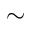<formula> <loc_0><loc_0><loc_500><loc_500>\sim</formula> 